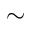<formula> <loc_0><loc_0><loc_500><loc_500>\sim</formula> 